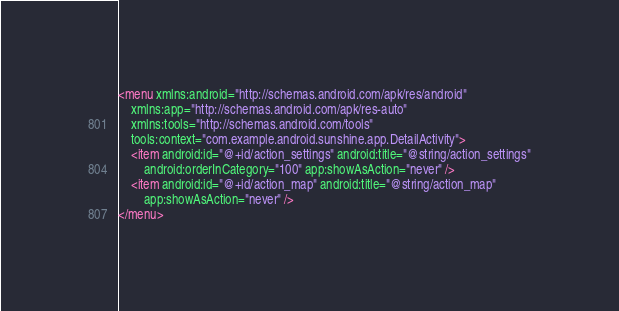<code> <loc_0><loc_0><loc_500><loc_500><_XML_><menu xmlns:android="http://schemas.android.com/apk/res/android"
    xmlns:app="http://schemas.android.com/apk/res-auto"
    xmlns:tools="http://schemas.android.com/tools"
    tools:context="com.example.android.sunshine.app.DetailActivity">
    <item android:id="@+id/action_settings" android:title="@string/action_settings"
        android:orderInCategory="100" app:showAsAction="never" />
    <item android:id="@+id/action_map" android:title="@string/action_map"
        app:showAsAction="never" />
</menu>
</code> 